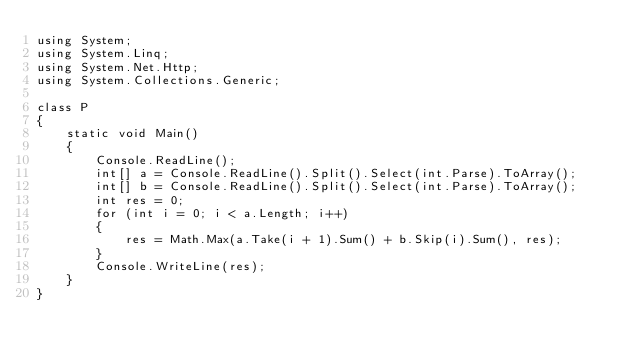<code> <loc_0><loc_0><loc_500><loc_500><_C#_>using System;
using System.Linq;
using System.Net.Http;
using System.Collections.Generic;

class P
{
    static void Main()
    {
        Console.ReadLine();
        int[] a = Console.ReadLine().Split().Select(int.Parse).ToArray();
        int[] b = Console.ReadLine().Split().Select(int.Parse).ToArray();
        int res = 0;
        for (int i = 0; i < a.Length; i++)
        {
            res = Math.Max(a.Take(i + 1).Sum() + b.Skip(i).Sum(), res);
        }
        Console.WriteLine(res);
    }
}</code> 